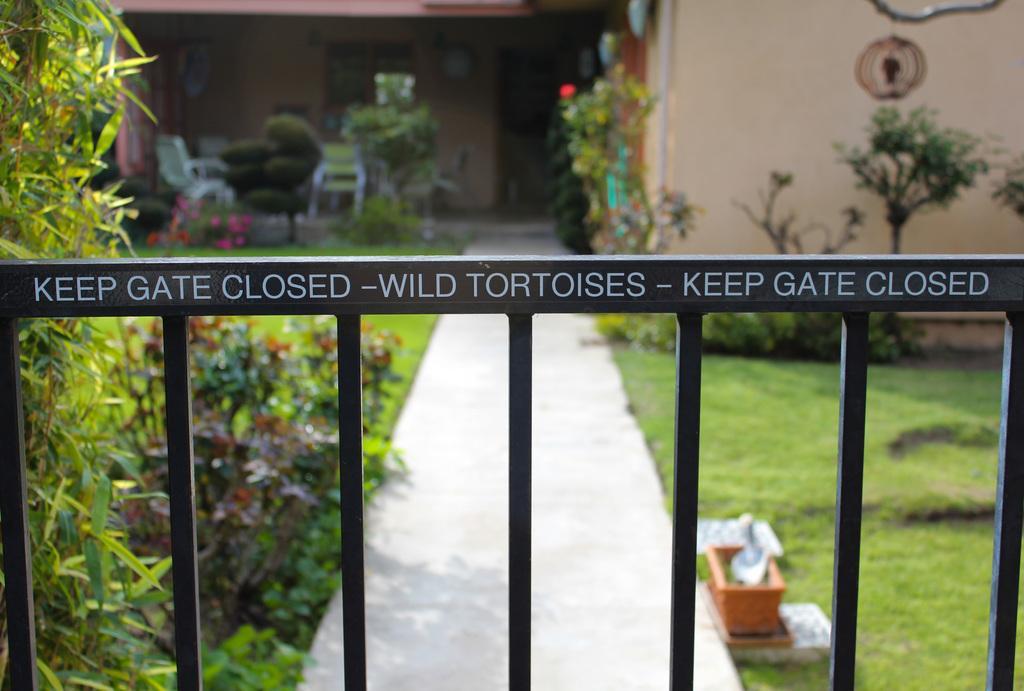How would you summarize this image in a sentence or two? In this image I can see a building , in front of the building I can see trees, flower pots, gate ,wall and plants. 